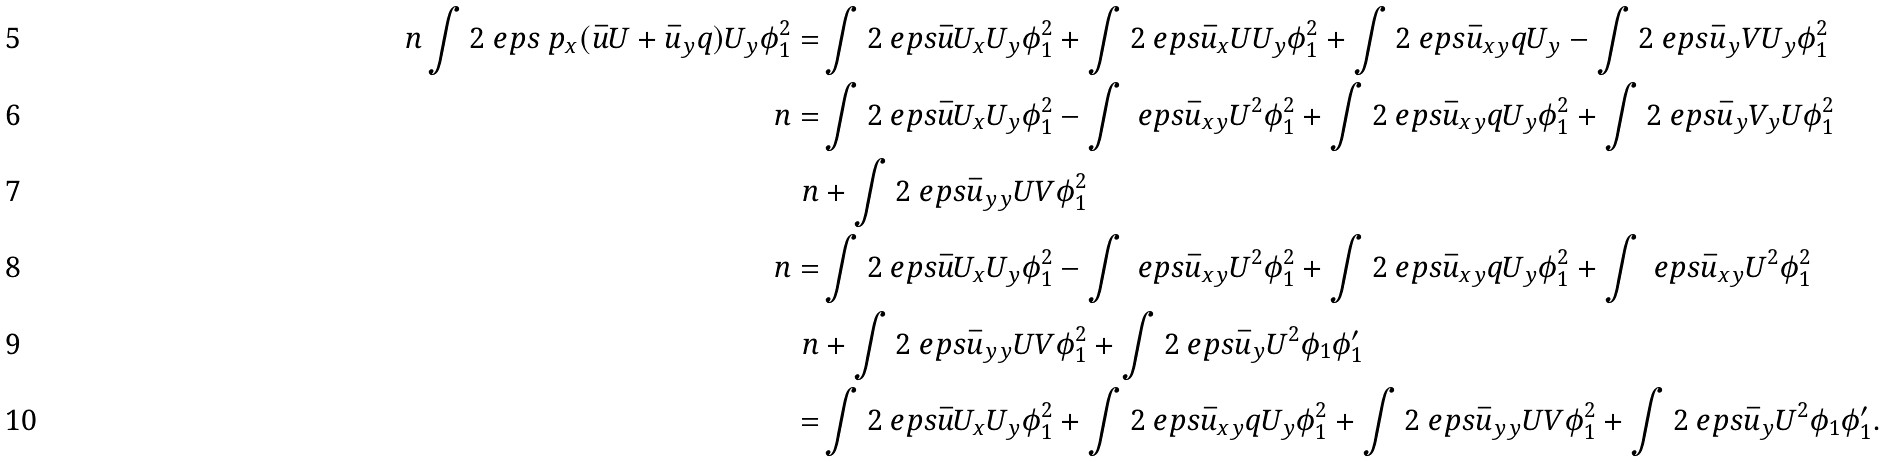Convert formula to latex. <formula><loc_0><loc_0><loc_500><loc_500>\ n \int 2 \ e p s \ p _ { x } ( \bar { u } U + \bar { u } _ { y } q ) U _ { y } \phi _ { 1 } ^ { 2 } = & \int 2 \ e p s \bar { u } U _ { x } U _ { y } \phi _ { 1 } ^ { 2 } + \int 2 \ e p s \bar { u } _ { x } U U _ { y } \phi _ { 1 } ^ { 2 } + \int 2 \ e p s \bar { u } _ { x y } q U _ { y } - \int 2 \ e p s \bar { u } _ { y } V U _ { y } \phi _ { 1 } ^ { 2 } \\ \ n = & \int 2 \ e p s \bar { u } U _ { x } U _ { y } \phi _ { 1 } ^ { 2 } - \int \ e p s \bar { u } _ { x y } U ^ { 2 } \phi _ { 1 } ^ { 2 } + \int 2 \ e p s \bar { u } _ { x y } q U _ { y } \phi _ { 1 } ^ { 2 } + \int 2 \ e p s \bar { u } _ { y } V _ { y } U \phi _ { 1 } ^ { 2 } \\ \ n & + \int 2 \ e p s \bar { u } _ { y y } U V \phi _ { 1 } ^ { 2 } \\ \ n = & \int 2 \ e p s \bar { u } U _ { x } U _ { y } \phi _ { 1 } ^ { 2 } - \int \ e p s \bar { u } _ { x y } U ^ { 2 } \phi _ { 1 } ^ { 2 } + \int 2 \ e p s \bar { u } _ { x y } q U _ { y } \phi _ { 1 } ^ { 2 } + \int \ e p s \bar { u } _ { x y } U ^ { 2 } \phi _ { 1 } ^ { 2 } \\ \ n & + \int 2 \ e p s \bar { u } _ { y y } U V \phi _ { 1 } ^ { 2 } + \int 2 \ e p s \bar { u } _ { y } U ^ { 2 } \phi _ { 1 } \phi _ { 1 } ^ { \prime } \\ = & \int 2 \ e p s \bar { u } U _ { x } U _ { y } \phi _ { 1 } ^ { 2 } + \int 2 \ e p s \bar { u } _ { x y } q U _ { y } \phi _ { 1 } ^ { 2 } + \int 2 \ e p s \bar { u } _ { y y } U V \phi _ { 1 } ^ { 2 } + \int 2 \ e p s \bar { u } _ { y } U ^ { 2 } \phi _ { 1 } \phi _ { 1 } ^ { \prime } .</formula> 